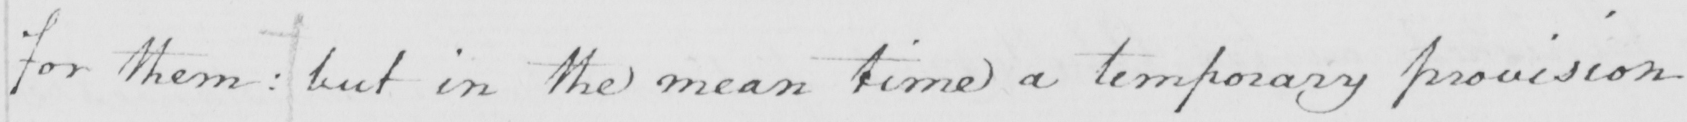Transcribe the text shown in this historical manuscript line. for them :  but in the mean time a temporary provision 